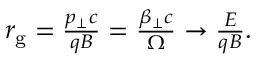<formula> <loc_0><loc_0><loc_500><loc_500>\begin{array} { r } { r _ { g } = \frac { p _ { \perp } c } { q B } = \frac { \beta _ { \perp } c } { \Omega } \to \frac { E } { q B } . } \end{array}</formula> 